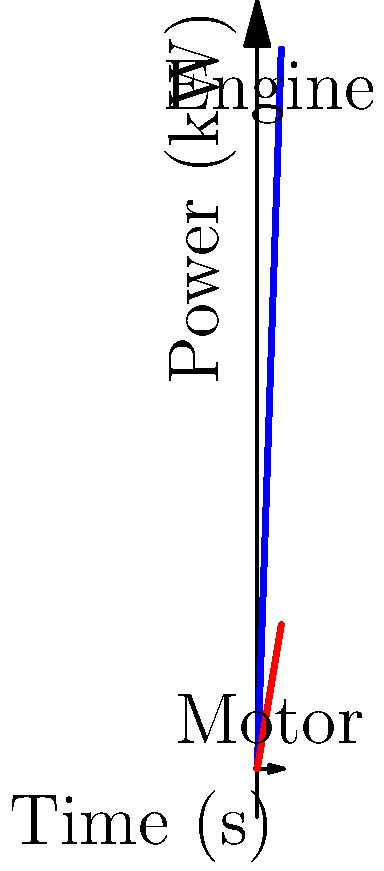Analyze the power flow diagram of a hybrid drivetrain shown above. At what point in time does the electric motor's power output equal 25% of the engine's power output? To solve this problem, we need to follow these steps:

1) Observe that the blue line represents the engine power output, which increases linearly over time.
2) The red line represents the electric motor's power output, which also increases linearly but at a slower rate.
3) We need to find the point where the motor's power is 25% of the engine's power.
4) At t = 5s, the engine power is 150 kW and the motor power is 30 kW.
5) We can set up the equation: $30 = 0.25 * 150$
6) This equation is true, confirming that at t = 5s, the motor power is indeed 25% of the engine power.
7) Given the linear nature of both power outputs, this relationship will only be true at this single point in time.

Therefore, at t = 5s, the electric motor's power output equals 25% of the engine's power output.
Answer: 5 seconds 